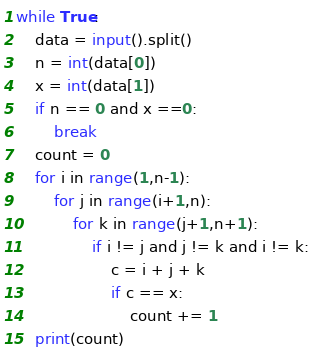<code> <loc_0><loc_0><loc_500><loc_500><_Python_>while True:
    data = input().split()
    n = int(data[0])
    x = int(data[1])
    if n == 0 and x ==0:
        break
    count = 0
    for i in range(1,n-1):
        for j in range(i+1,n):
            for k in range(j+1,n+1):
                if i != j and j != k and i != k:
                    c = i + j + k
                    if c == x:
                        count += 1
    print(count)</code> 